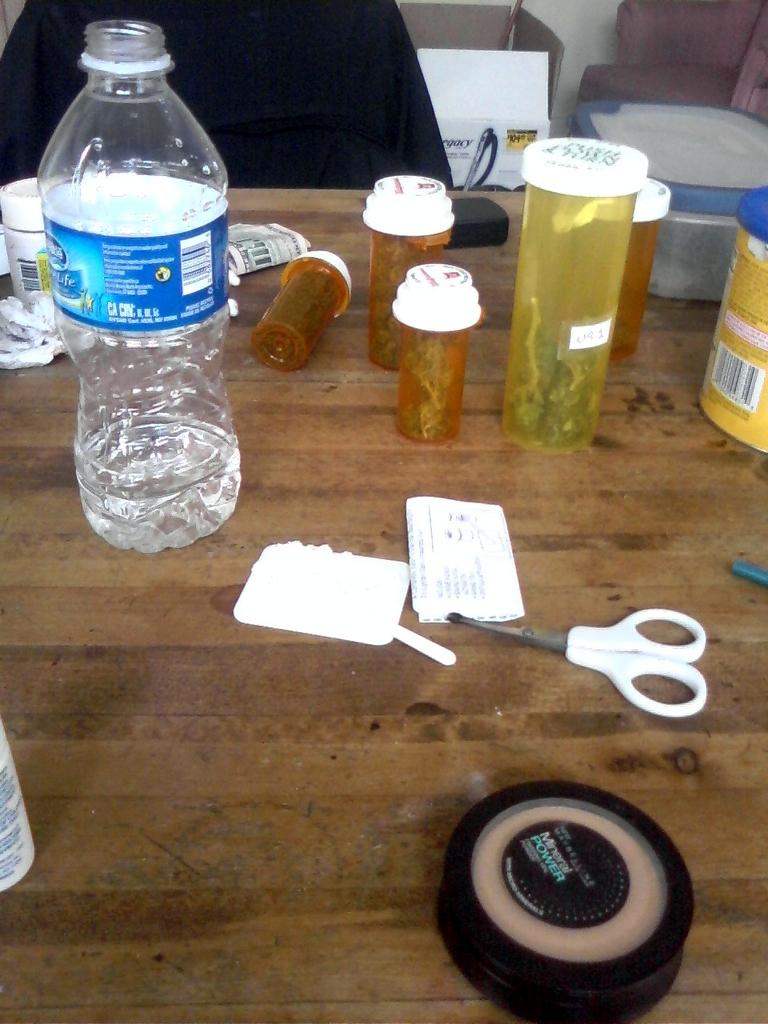What type of object can be seen in the image that is typically used for holding liquids? There is a bottle in the image. What other objects in the image are used for holding items? There are jars and containers in the image. What objects in the image are used for cutting? There are scissors in the image. What type of material are the papers in the image made of? The papers in the image are made of paper. Where are the objects in the image located? The objects are on a table. What type of box is present in the image? There is a cardboard box in the image. What type of ball is being used by the judge at the party in the image? There is no judge, party, or ball present in the image. 